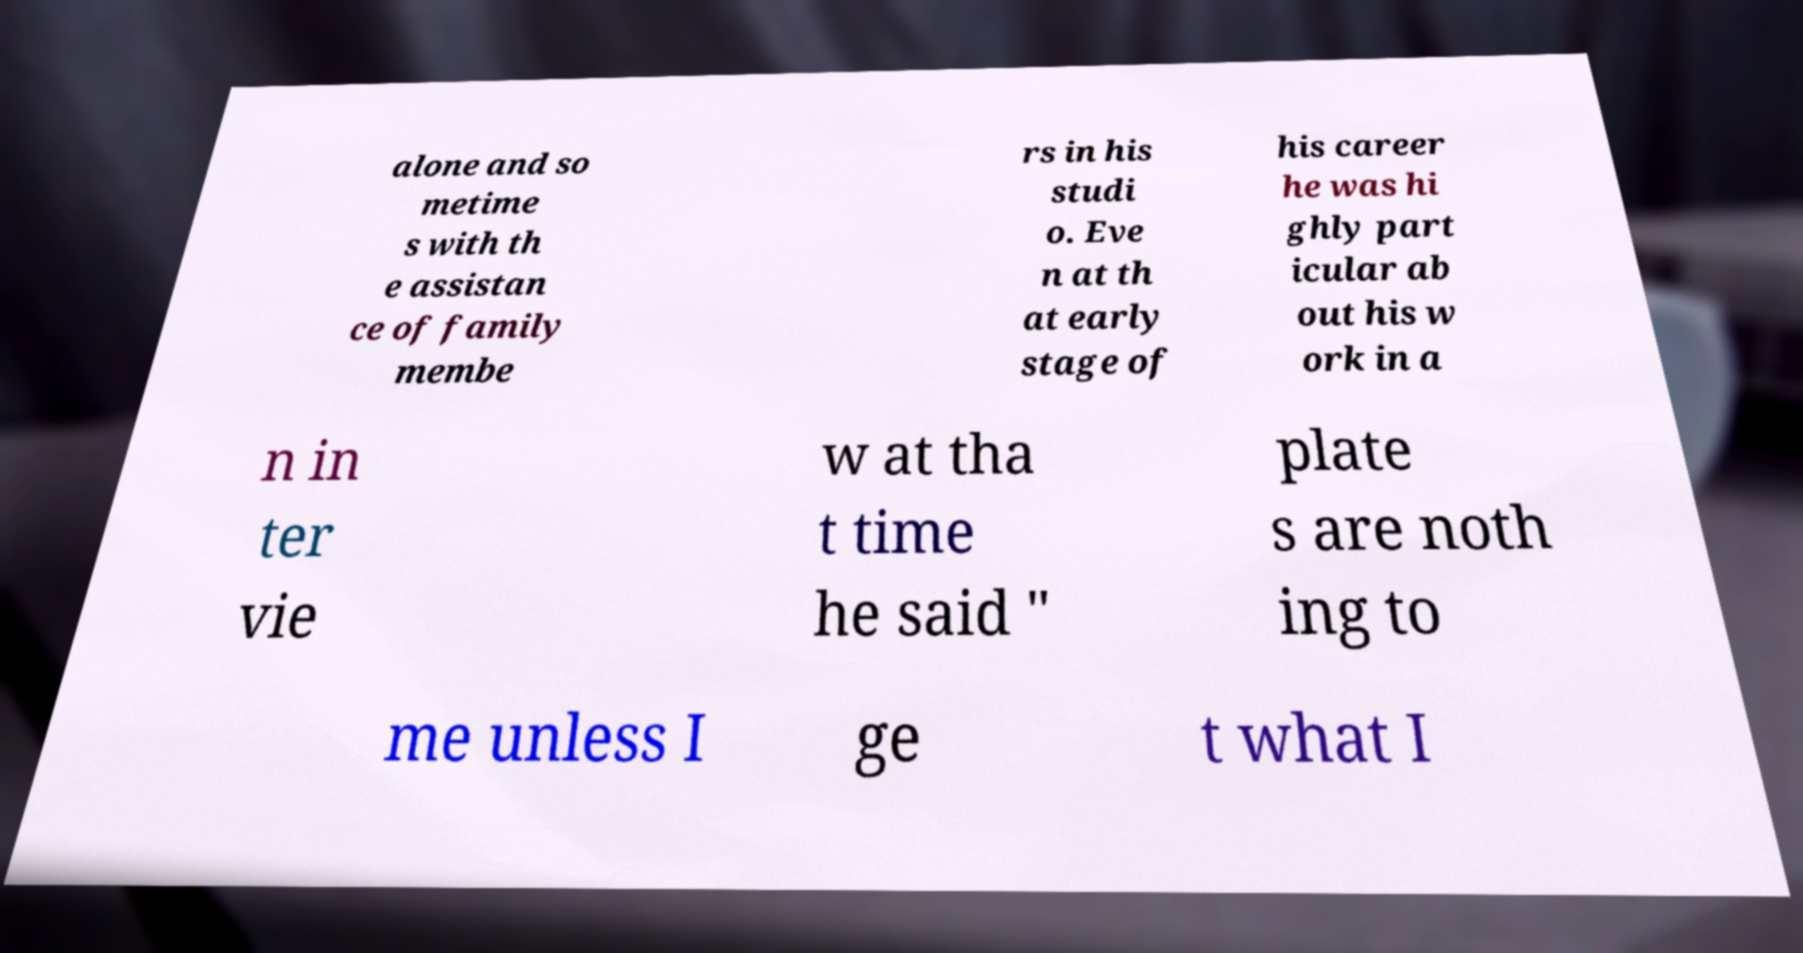For documentation purposes, I need the text within this image transcribed. Could you provide that? alone and so metime s with th e assistan ce of family membe rs in his studi o. Eve n at th at early stage of his career he was hi ghly part icular ab out his w ork in a n in ter vie w at tha t time he said " plate s are noth ing to me unless I ge t what I 